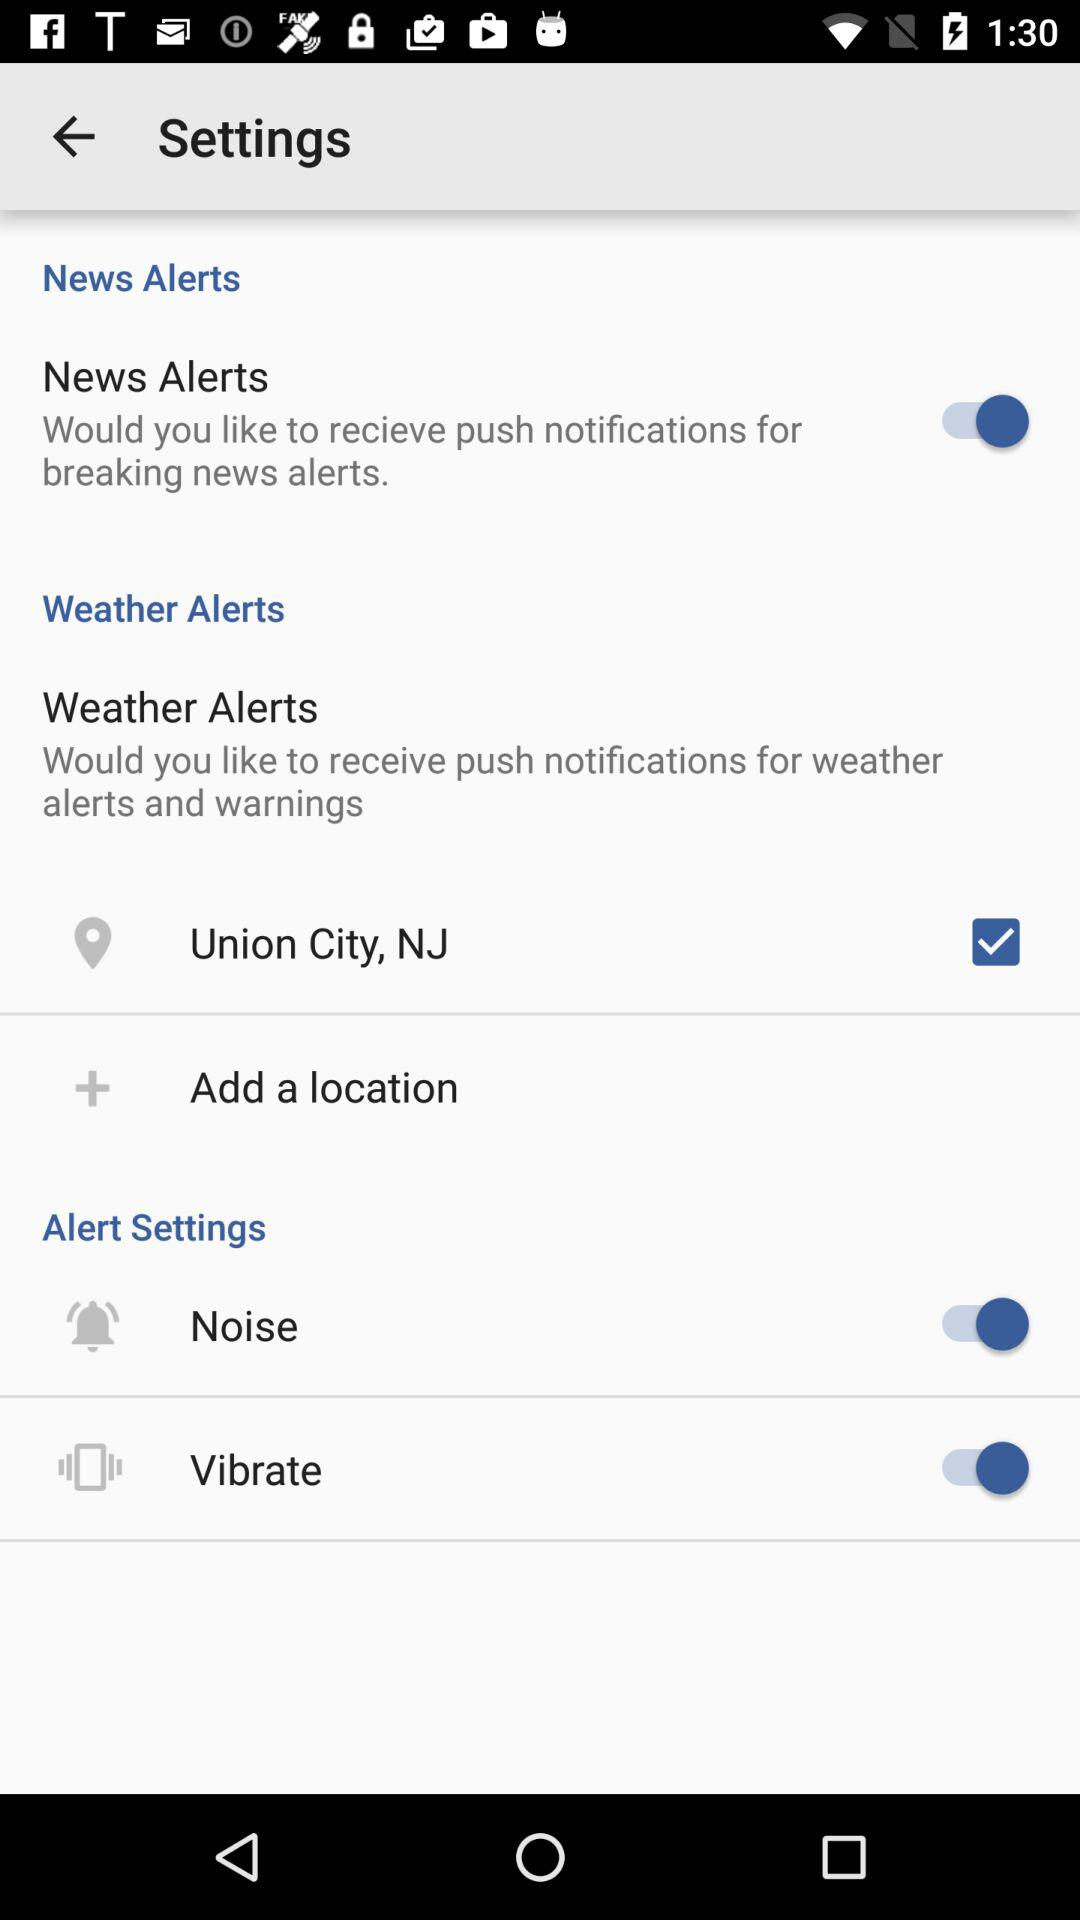What is the location? The location is Union City, NJ. 